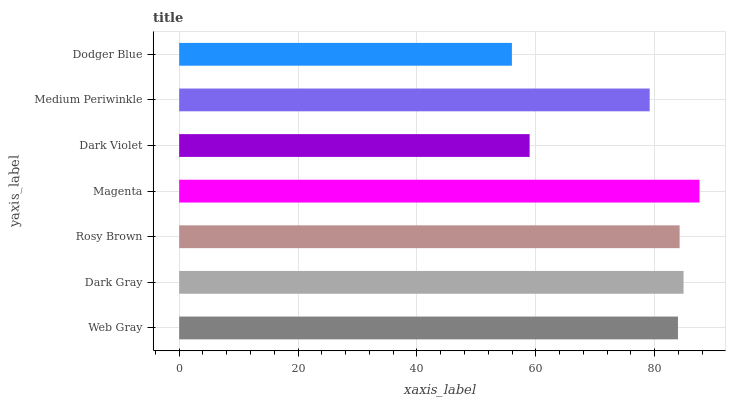Is Dodger Blue the minimum?
Answer yes or no. Yes. Is Magenta the maximum?
Answer yes or no. Yes. Is Dark Gray the minimum?
Answer yes or no. No. Is Dark Gray the maximum?
Answer yes or no. No. Is Dark Gray greater than Web Gray?
Answer yes or no. Yes. Is Web Gray less than Dark Gray?
Answer yes or no. Yes. Is Web Gray greater than Dark Gray?
Answer yes or no. No. Is Dark Gray less than Web Gray?
Answer yes or no. No. Is Web Gray the high median?
Answer yes or no. Yes. Is Web Gray the low median?
Answer yes or no. Yes. Is Rosy Brown the high median?
Answer yes or no. No. Is Rosy Brown the low median?
Answer yes or no. No. 